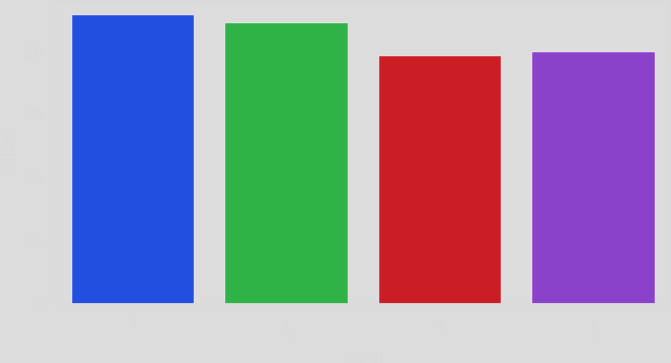Convert chart. <chart><loc_0><loc_0><loc_500><loc_500><bar_chart><fcel>First<fcel>Second<fcel>Third<fcel>Fourth<nl><fcel>91.74<fcel>89.17<fcel>78.76<fcel>80.06<nl></chart> 